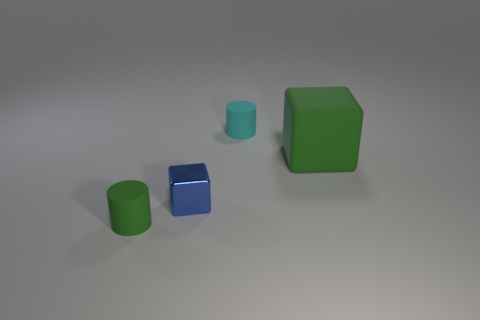Add 1 cylinders. How many objects exist? 5 Subtract all tiny green cylinders. Subtract all blue blocks. How many objects are left? 2 Add 1 small blue shiny cubes. How many small blue shiny cubes are left? 2 Add 2 big gray balls. How many big gray balls exist? 2 Subtract 0 brown blocks. How many objects are left? 4 